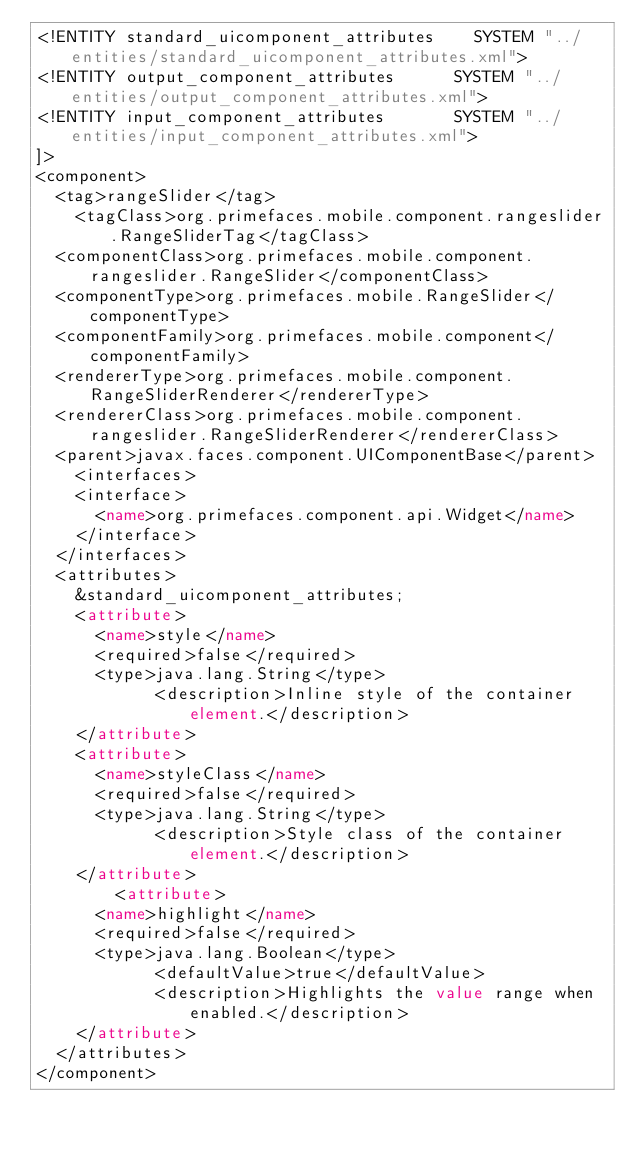Convert code to text. <code><loc_0><loc_0><loc_500><loc_500><_XML_><!ENTITY standard_uicomponent_attributes		SYSTEM "../entities/standard_uicomponent_attributes.xml">
<!ENTITY output_component_attributes			SYSTEM "../entities/output_component_attributes.xml">
<!ENTITY input_component_attributes				SYSTEM "../entities/input_component_attributes.xml">
]>
<component>
	<tag>rangeSlider</tag>
    <tagClass>org.primefaces.mobile.component.rangeslider.RangeSliderTag</tagClass>
	<componentClass>org.primefaces.mobile.component.rangeslider.RangeSlider</componentClass>
	<componentType>org.primefaces.mobile.RangeSlider</componentType>
	<componentFamily>org.primefaces.mobile.component</componentFamily>
	<rendererType>org.primefaces.mobile.component.RangeSliderRenderer</rendererType>
	<rendererClass>org.primefaces.mobile.component.rangeslider.RangeSliderRenderer</rendererClass>
	<parent>javax.faces.component.UIComponentBase</parent>
    <interfaces>
		<interface>
			<name>org.primefaces.component.api.Widget</name>
		</interface>
	</interfaces>
	<attributes>
		&standard_uicomponent_attributes;
		<attribute>
			<name>style</name>
			<required>false</required>
			<type>java.lang.String</type>
            <description>Inline style of the container element.</description>
		</attribute>
		<attribute>
			<name>styleClass</name>
			<required>false</required>
			<type>java.lang.String</type>
            <description>Style class of the container element.</description>
		</attribute>
        <attribute>
			<name>highlight</name>
			<required>false</required>
			<type>java.lang.Boolean</type>
            <defaultValue>true</defaultValue>
            <description>Highlights the value range when enabled.</description>
		</attribute>
	</attributes>
</component></code> 